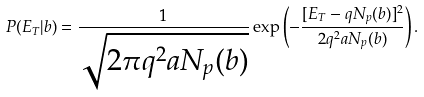Convert formula to latex. <formula><loc_0><loc_0><loc_500><loc_500>P ( E _ { T } | b ) = \frac { 1 } { \sqrt { 2 \pi q ^ { 2 } a N _ { p } ( b ) } } \exp \left ( - \frac { [ E _ { T } - q N _ { p } ( b ) ] ^ { 2 } } { 2 q ^ { 2 } a N _ { p } ( b ) } \right ) .</formula> 